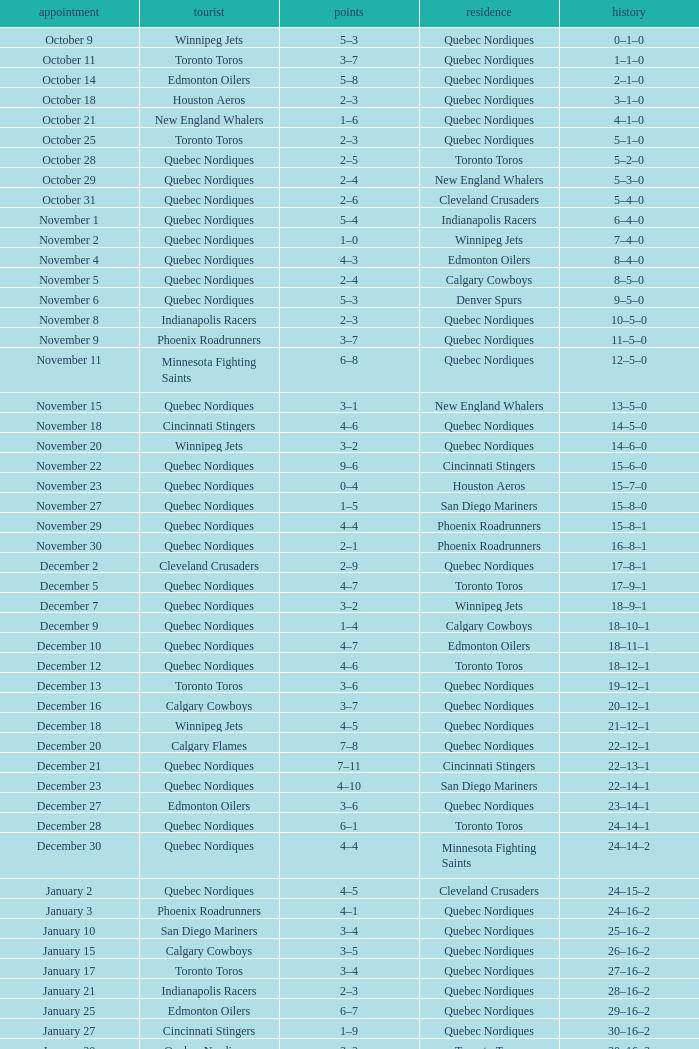What was the score of the game when the record was 39–21–4? 5–4. 